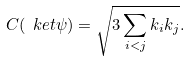Convert formula to latex. <formula><loc_0><loc_0><loc_500><loc_500>C ( \ k e t { \psi } ) = \sqrt { 3 \sum _ { i < j } k _ { i } k _ { j } } .</formula> 